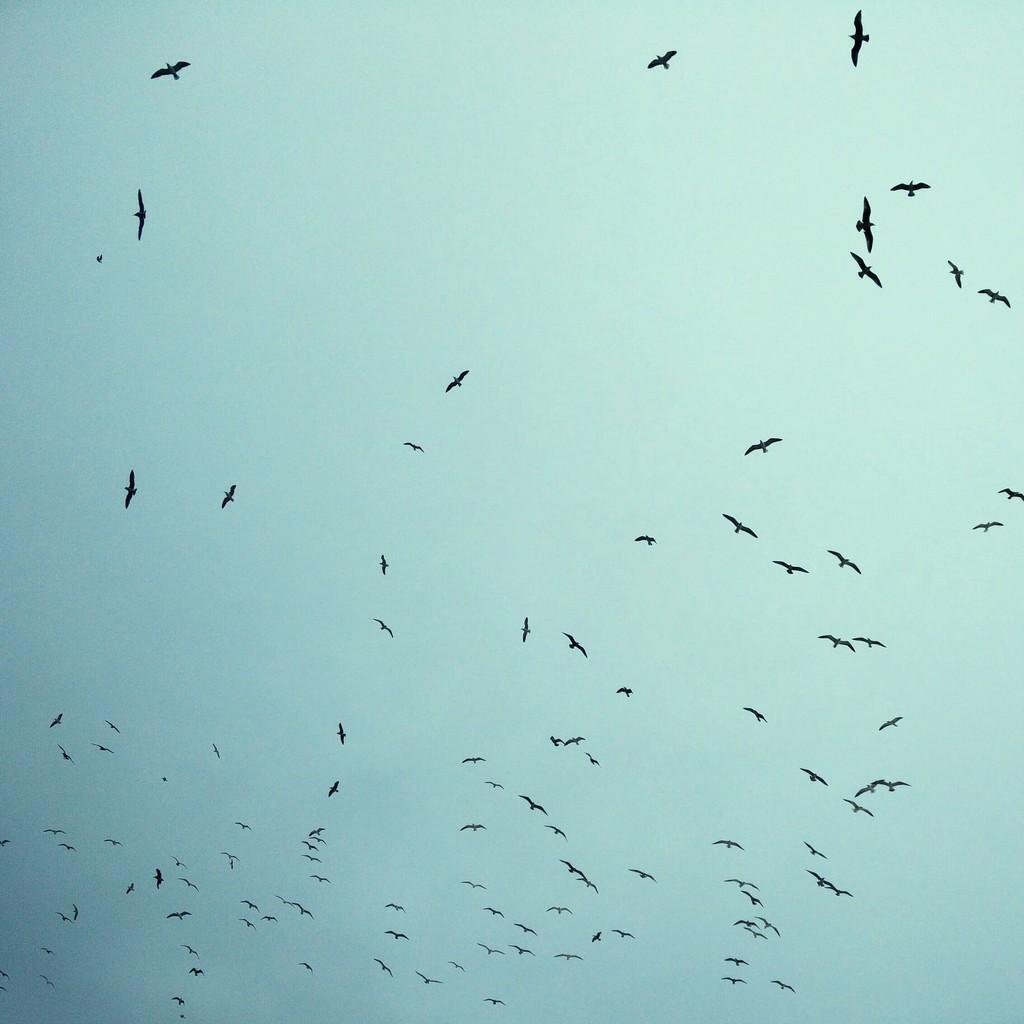Could you give a brief overview of what you see in this image? In this picture I can see there are few birds flying in the sky and the sky is clear. 